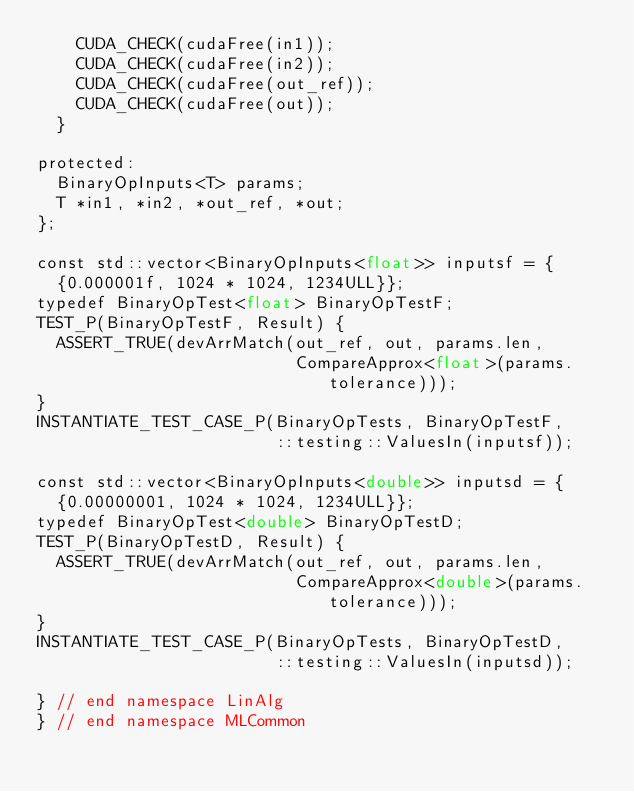Convert code to text. <code><loc_0><loc_0><loc_500><loc_500><_Cuda_>    CUDA_CHECK(cudaFree(in1));
    CUDA_CHECK(cudaFree(in2));
    CUDA_CHECK(cudaFree(out_ref));
    CUDA_CHECK(cudaFree(out));
  }

protected:
  BinaryOpInputs<T> params;
  T *in1, *in2, *out_ref, *out;
};

const std::vector<BinaryOpInputs<float>> inputsf = {
  {0.000001f, 1024 * 1024, 1234ULL}};
typedef BinaryOpTest<float> BinaryOpTestF;
TEST_P(BinaryOpTestF, Result) {
  ASSERT_TRUE(devArrMatch(out_ref, out, params.len,
                          CompareApprox<float>(params.tolerance)));
}
INSTANTIATE_TEST_CASE_P(BinaryOpTests, BinaryOpTestF,
                        ::testing::ValuesIn(inputsf));

const std::vector<BinaryOpInputs<double>> inputsd = {
  {0.00000001, 1024 * 1024, 1234ULL}};
typedef BinaryOpTest<double> BinaryOpTestD;
TEST_P(BinaryOpTestD, Result) {
  ASSERT_TRUE(devArrMatch(out_ref, out, params.len,
                          CompareApprox<double>(params.tolerance)));
}
INSTANTIATE_TEST_CASE_P(BinaryOpTests, BinaryOpTestD,
                        ::testing::ValuesIn(inputsd));

} // end namespace LinAlg
} // end namespace MLCommon
</code> 